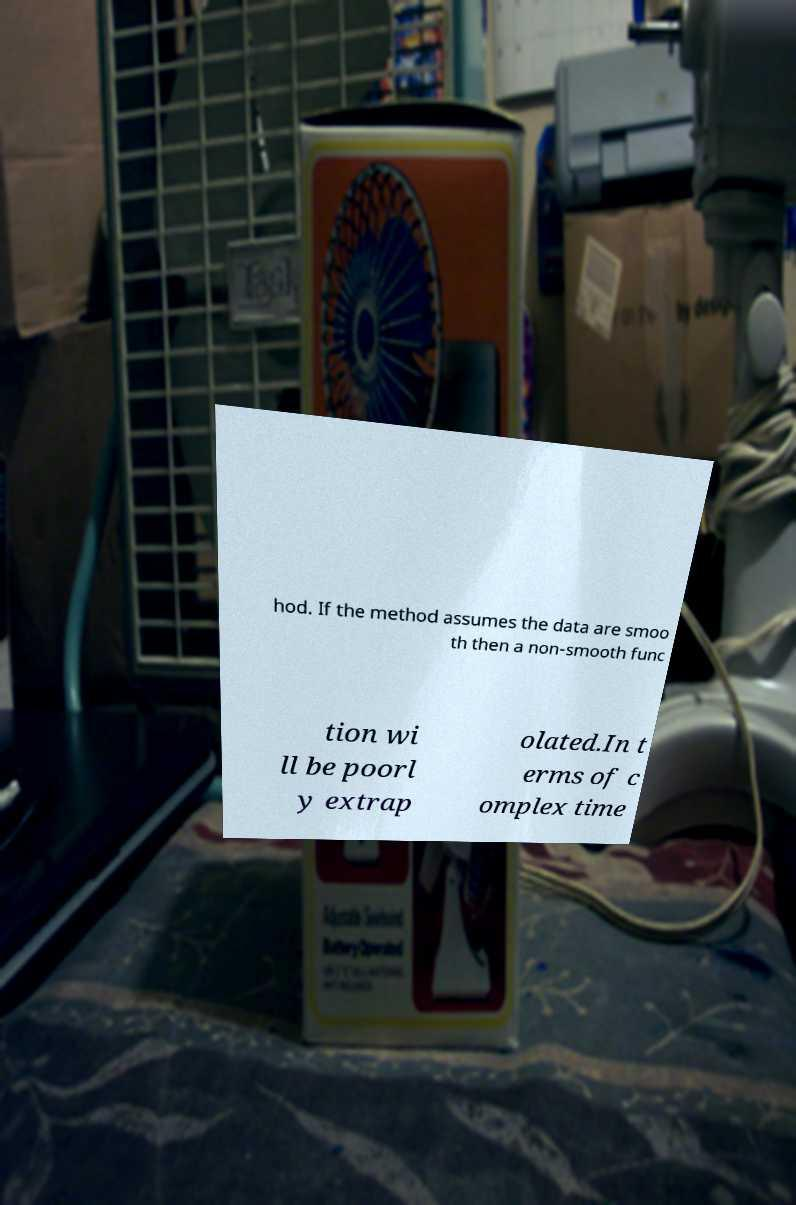Please identify and transcribe the text found in this image. hod. If the method assumes the data are smoo th then a non-smooth func tion wi ll be poorl y extrap olated.In t erms of c omplex time 